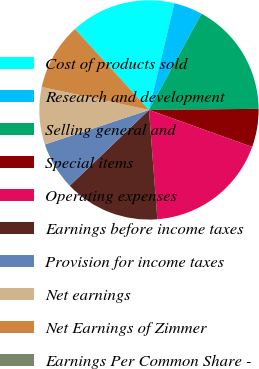Convert chart. <chart><loc_0><loc_0><loc_500><loc_500><pie_chart><fcel>Cost of products sold<fcel>Research and development<fcel>Selling general and<fcel>Special items<fcel>Operating expenses<fcel>Earnings before income taxes<fcel>Provision for income taxes<fcel>Net earnings<fcel>Net Earnings of Zimmer<fcel>Earnings Per Common Share -<nl><fcel>15.48%<fcel>4.24%<fcel>16.89%<fcel>5.64%<fcel>18.3%<fcel>14.08%<fcel>7.05%<fcel>8.45%<fcel>9.86%<fcel>0.02%<nl></chart> 